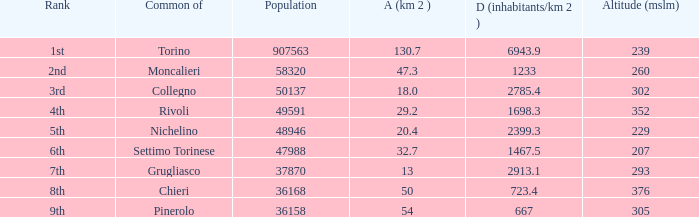What rank is the common with an area of 47.3 km^2? 2nd. 